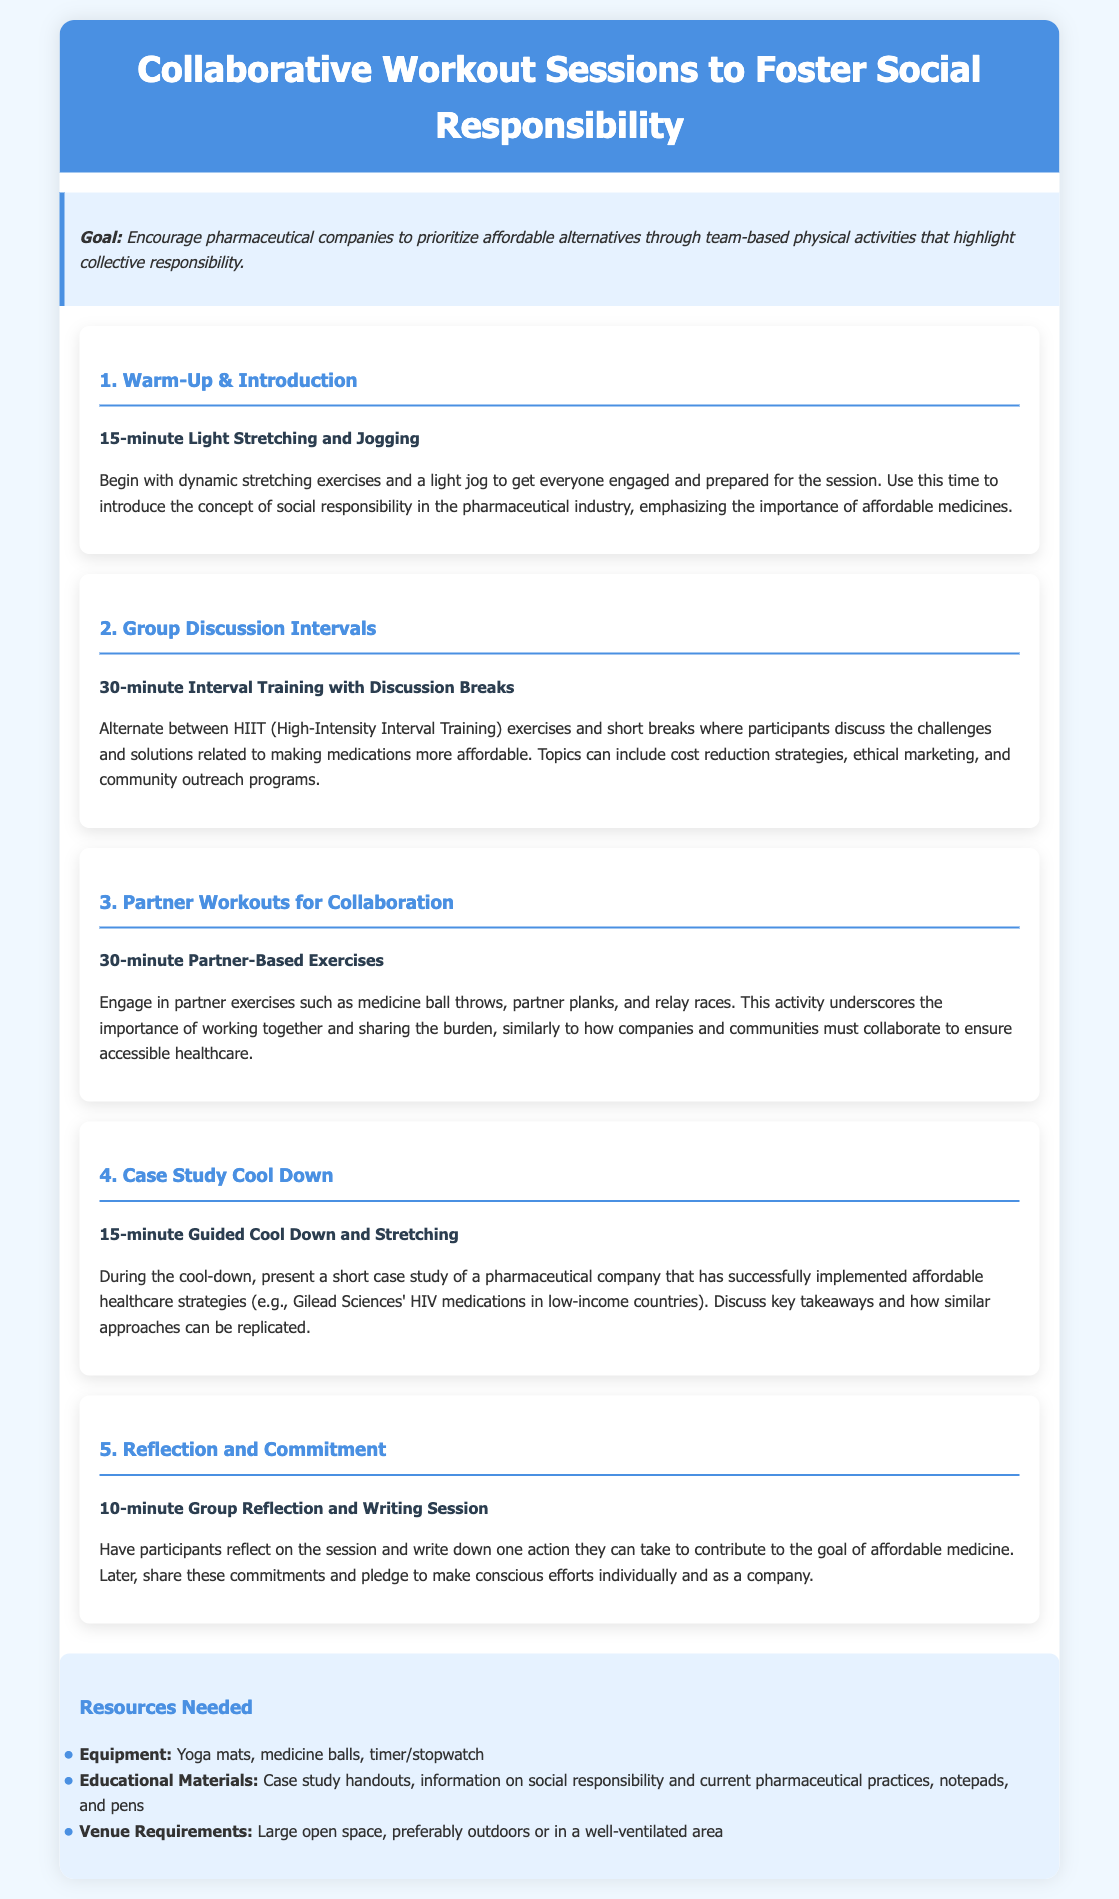What is the goal of the workout sessions? The goal is to encourage pharmaceutical companies to prioritize affordable alternatives through team-based physical activities that highlight collective responsibility.
Answer: encourage pharmaceutical companies to prioritize affordable alternatives How long is the warm-up session? The warm-up session, consisting of light stretching and jogging, lasts for 15 minutes as stated in the document.
Answer: 15 minutes What type of training is used in the second session? The second session involves High-Intensity Interval Training (HIIT) exercises interspersed with discussion breaks.
Answer: HIIT What is discussed during the partner workouts? The partner workouts emphasize the importance of collaboration and sharing the burden, similar to the collaboration needed for accessible healthcare.
Answer: collaboration and sharing the burden How long is the reflection and commitment session? The group reflection and writing session lasts for 10 minutes according to the session details provided.
Answer: 10 minutes What resources are needed for the workout? Equipment needed includes yoga mats, medicine balls, and a timer/stopwatch as outlined in the resources section.
Answer: yoga mats, medicine balls, timer/stopwatch Which company is presented as a case study during the cool down? Gilead Sciences is mentioned as the company that has successfully implemented affordable healthcare strategies.
Answer: Gilead Sciences What is the total duration of the planned workout sessions? The total duration is calculated from the individual session times provided in the document, which adds up to 100 minutes.
Answer: 100 minutes 